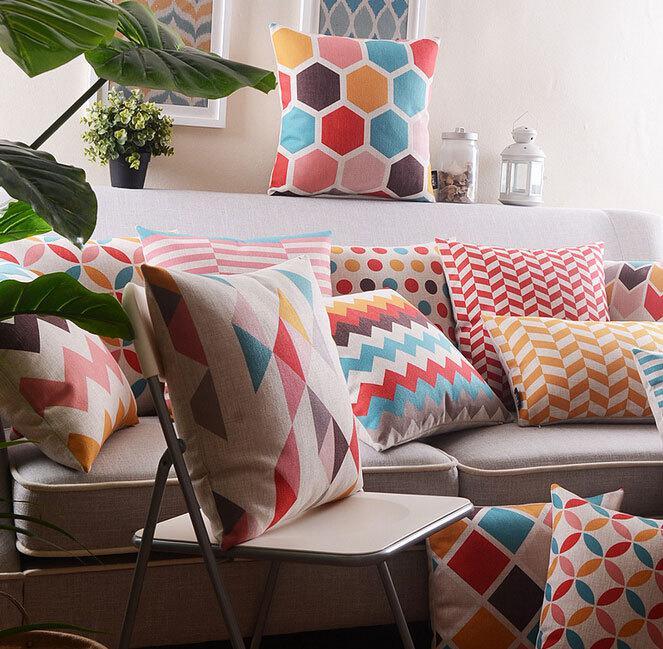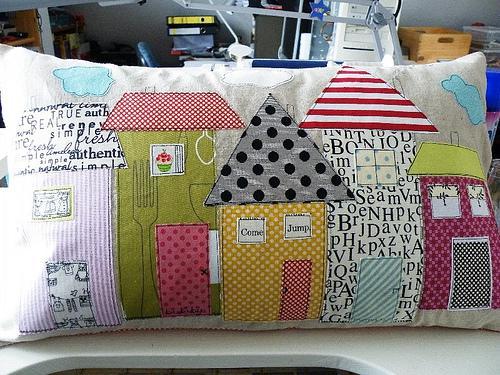The first image is the image on the left, the second image is the image on the right. Considering the images on both sides, is "At least one piece of fabric has flowers on it." valid? Answer yes or no. No. 